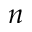<formula> <loc_0><loc_0><loc_500><loc_500>n</formula> 